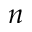<formula> <loc_0><loc_0><loc_500><loc_500>n</formula> 